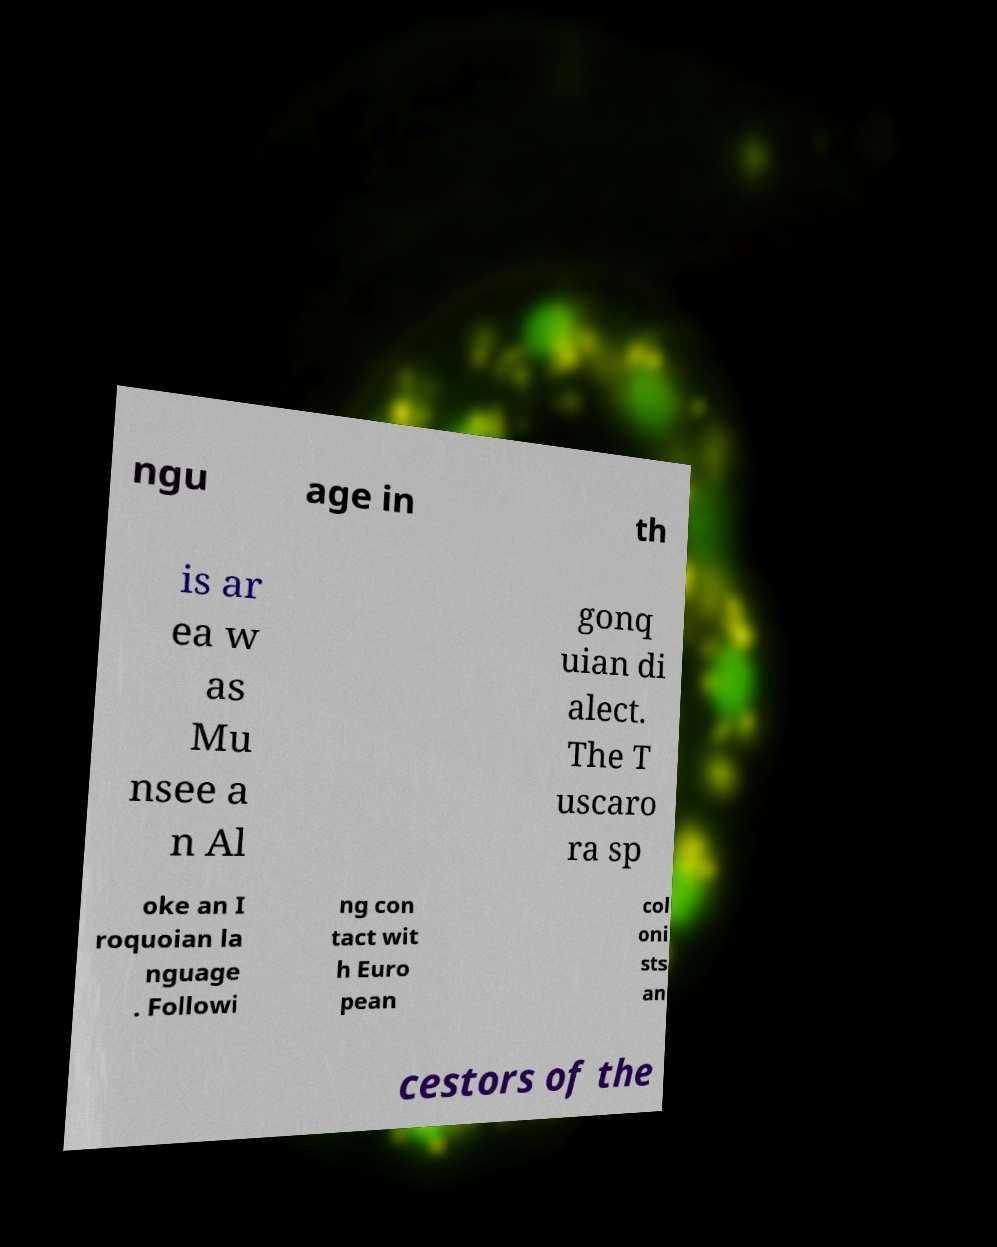Could you assist in decoding the text presented in this image and type it out clearly? ngu age in th is ar ea w as Mu nsee a n Al gonq uian di alect. The T uscaro ra sp oke an I roquoian la nguage . Followi ng con tact wit h Euro pean col oni sts an cestors of the 